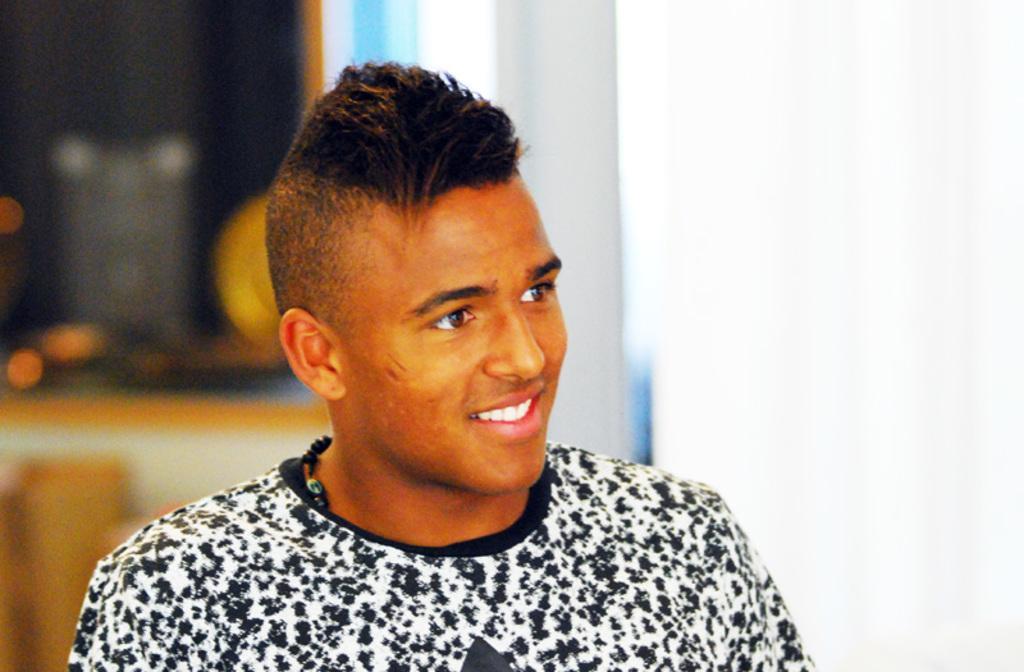Describe this image in one or two sentences. In this image we can see a man smiling. In the background it is looking blur. 